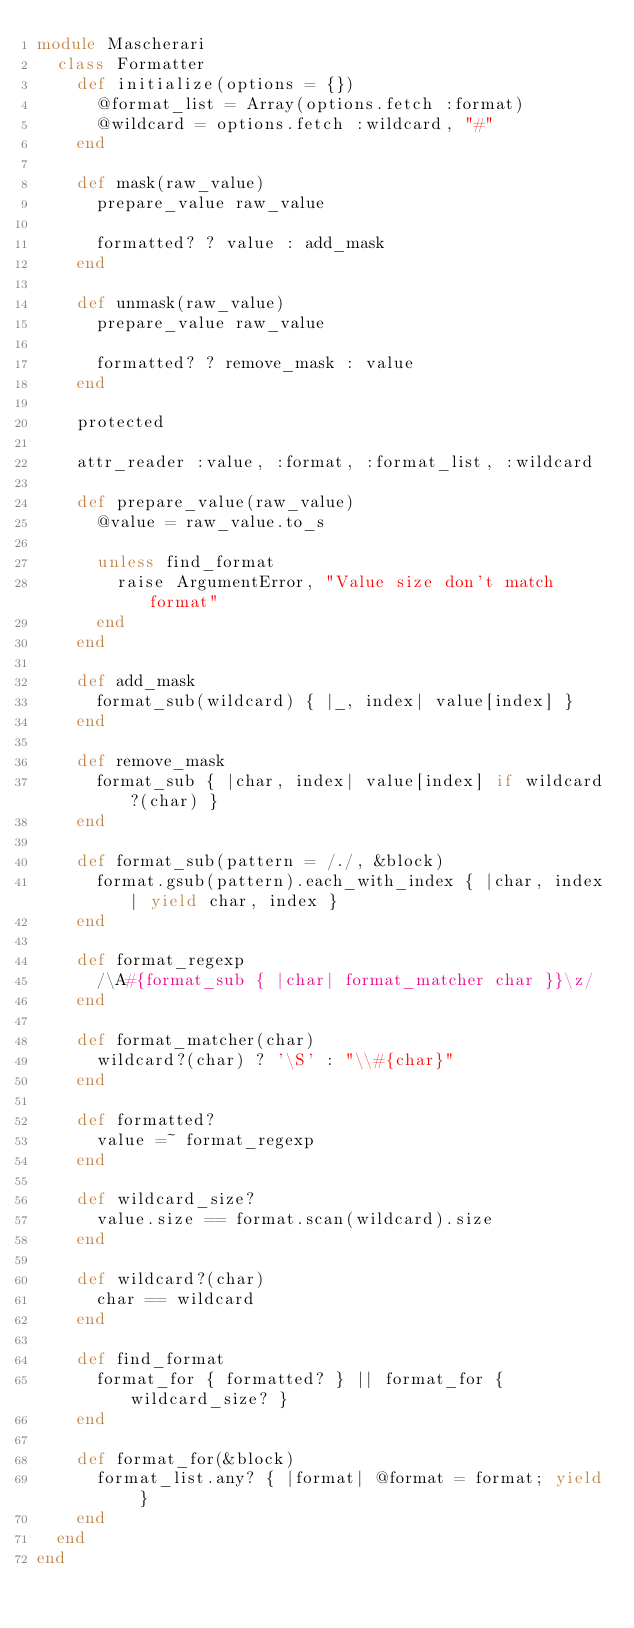Convert code to text. <code><loc_0><loc_0><loc_500><loc_500><_Ruby_>module Mascherari
  class Formatter
    def initialize(options = {})
      @format_list = Array(options.fetch :format)
      @wildcard = options.fetch :wildcard, "#"
    end

    def mask(raw_value)
      prepare_value raw_value

      formatted? ? value : add_mask
    end

    def unmask(raw_value)
      prepare_value raw_value

      formatted? ? remove_mask : value
    end

    protected

    attr_reader :value, :format, :format_list, :wildcard

    def prepare_value(raw_value)
      @value = raw_value.to_s

      unless find_format
        raise ArgumentError, "Value size don't match format"
      end
    end

    def add_mask
      format_sub(wildcard) { |_, index| value[index] }
    end

    def remove_mask
      format_sub { |char, index| value[index] if wildcard?(char) }
    end

    def format_sub(pattern = /./, &block)
      format.gsub(pattern).each_with_index { |char, index| yield char, index }
    end

    def format_regexp
      /\A#{format_sub { |char| format_matcher char }}\z/
    end

    def format_matcher(char)
      wildcard?(char) ? '\S' : "\\#{char}"
    end

    def formatted?
      value =~ format_regexp
    end

    def wildcard_size?
      value.size == format.scan(wildcard).size
    end

    def wildcard?(char)
      char == wildcard
    end

    def find_format
      format_for { formatted? } || format_for { wildcard_size? }
    end

    def format_for(&block)
      format_list.any? { |format| @format = format; yield }
    end
  end
end
</code> 